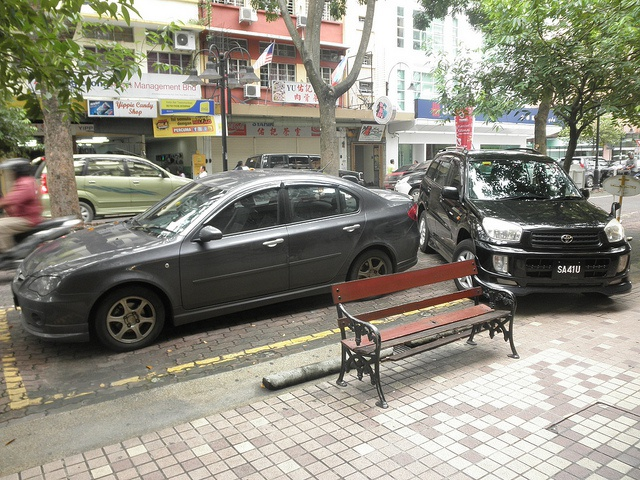Describe the objects in this image and their specific colors. I can see car in darkgreen, black, gray, darkgray, and lightgray tones, car in darkgreen, black, gray, white, and darkgray tones, bench in darkgreen, black, darkgray, maroon, and gray tones, car in darkgreen, gray, darkgray, and ivory tones, and people in darkgreen, brown, maroon, gray, and black tones in this image. 